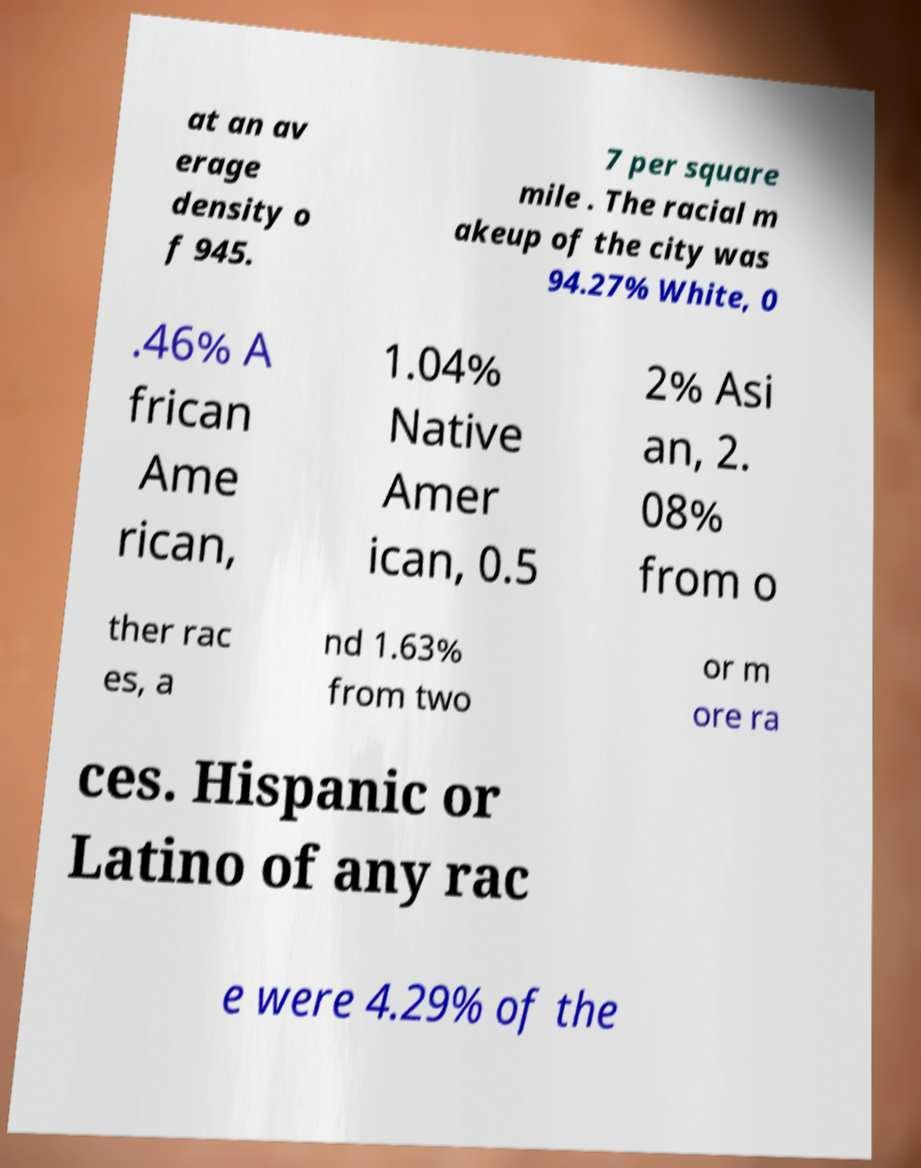Could you assist in decoding the text presented in this image and type it out clearly? at an av erage density o f 945. 7 per square mile . The racial m akeup of the city was 94.27% White, 0 .46% A frican Ame rican, 1.04% Native Amer ican, 0.5 2% Asi an, 2. 08% from o ther rac es, a nd 1.63% from two or m ore ra ces. Hispanic or Latino of any rac e were 4.29% of the 